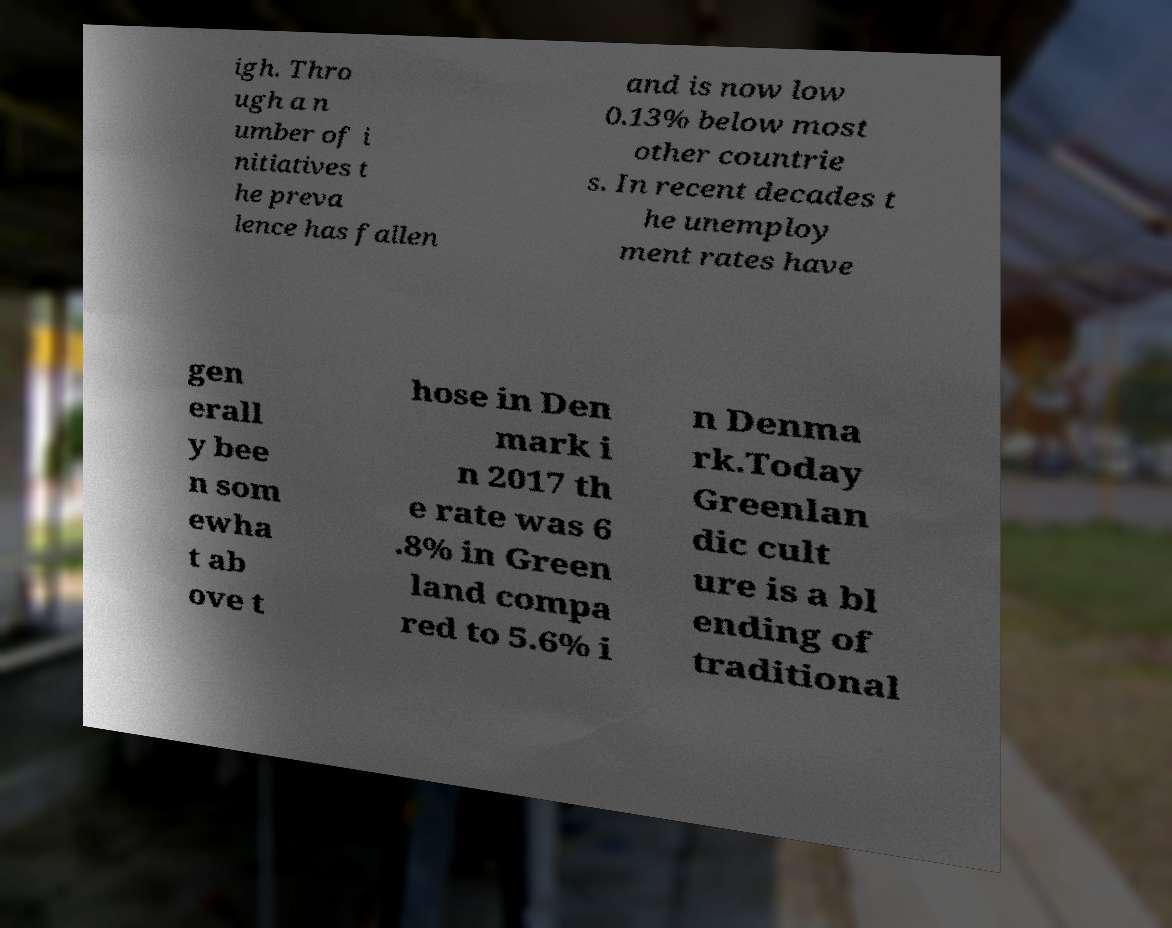Please read and relay the text visible in this image. What does it say? igh. Thro ugh a n umber of i nitiatives t he preva lence has fallen and is now low 0.13% below most other countrie s. In recent decades t he unemploy ment rates have gen erall y bee n som ewha t ab ove t hose in Den mark i n 2017 th e rate was 6 .8% in Green land compa red to 5.6% i n Denma rk.Today Greenlan dic cult ure is a bl ending of traditional 